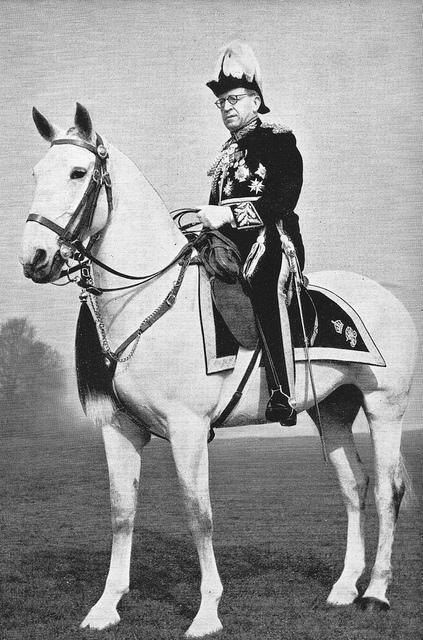How many train cars are shown?
Give a very brief answer. 0. 